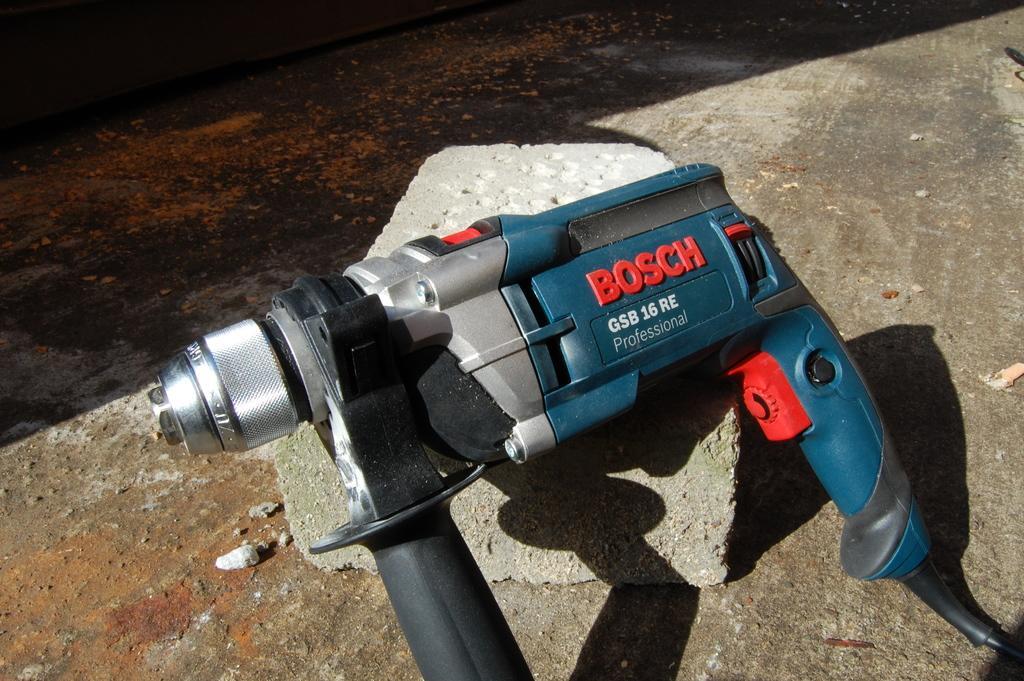Describe this image in one or two sentences. In the center of the image there is a drilling machine on the stone. At the bottom of the image there is floor. 